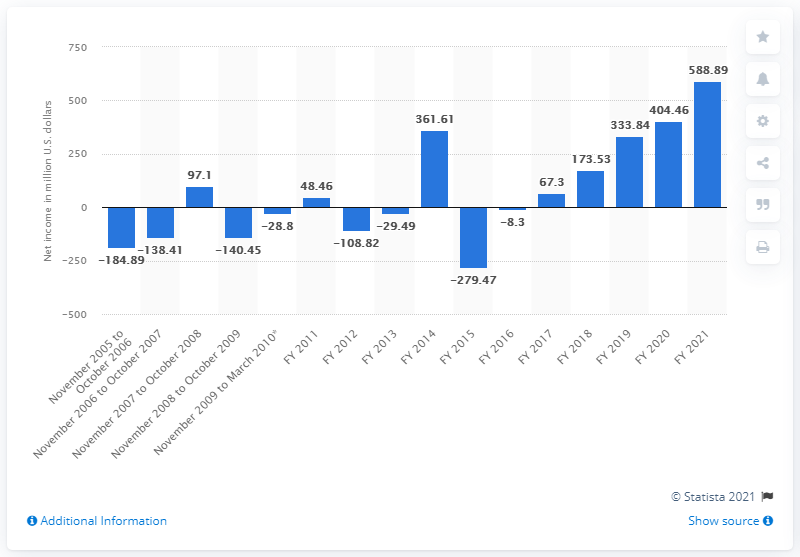What was Take-Two Interactive's net income in 2021?
 588.89 